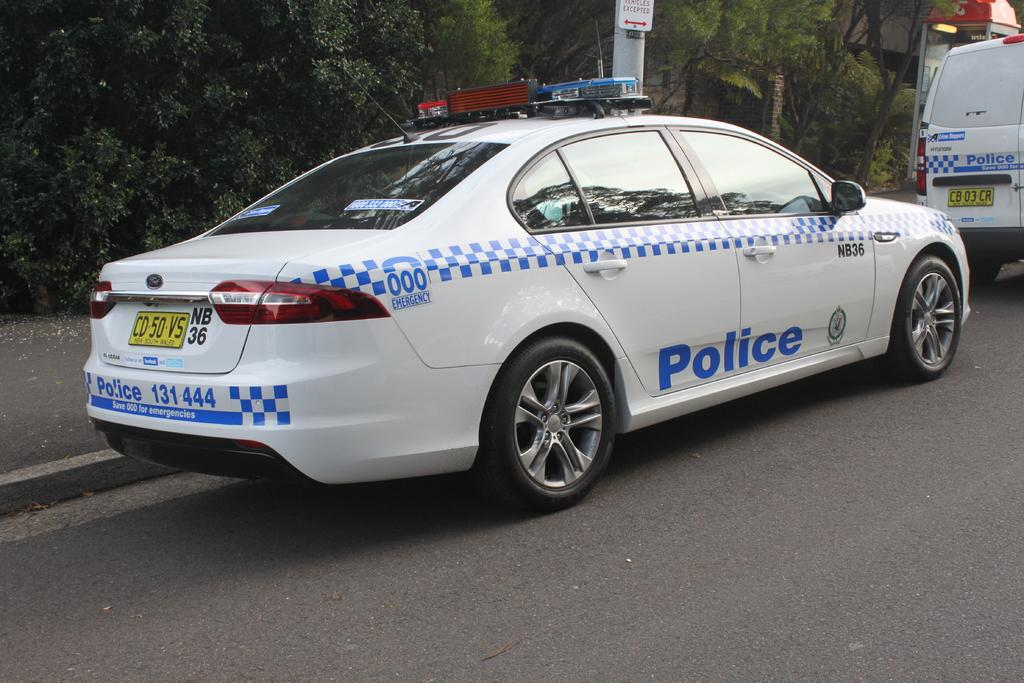What can be seen on the road in the image? There are cars on the road in the image. What is visible in the background of the image? There are trees, a pole, and houses in the background of the image. When was the image taken? The image was taken during the day. What type of riddle is being solved by the crowd in the image? There is no crowd present in the image, and therefore no riddle-solving activity can be observed. 